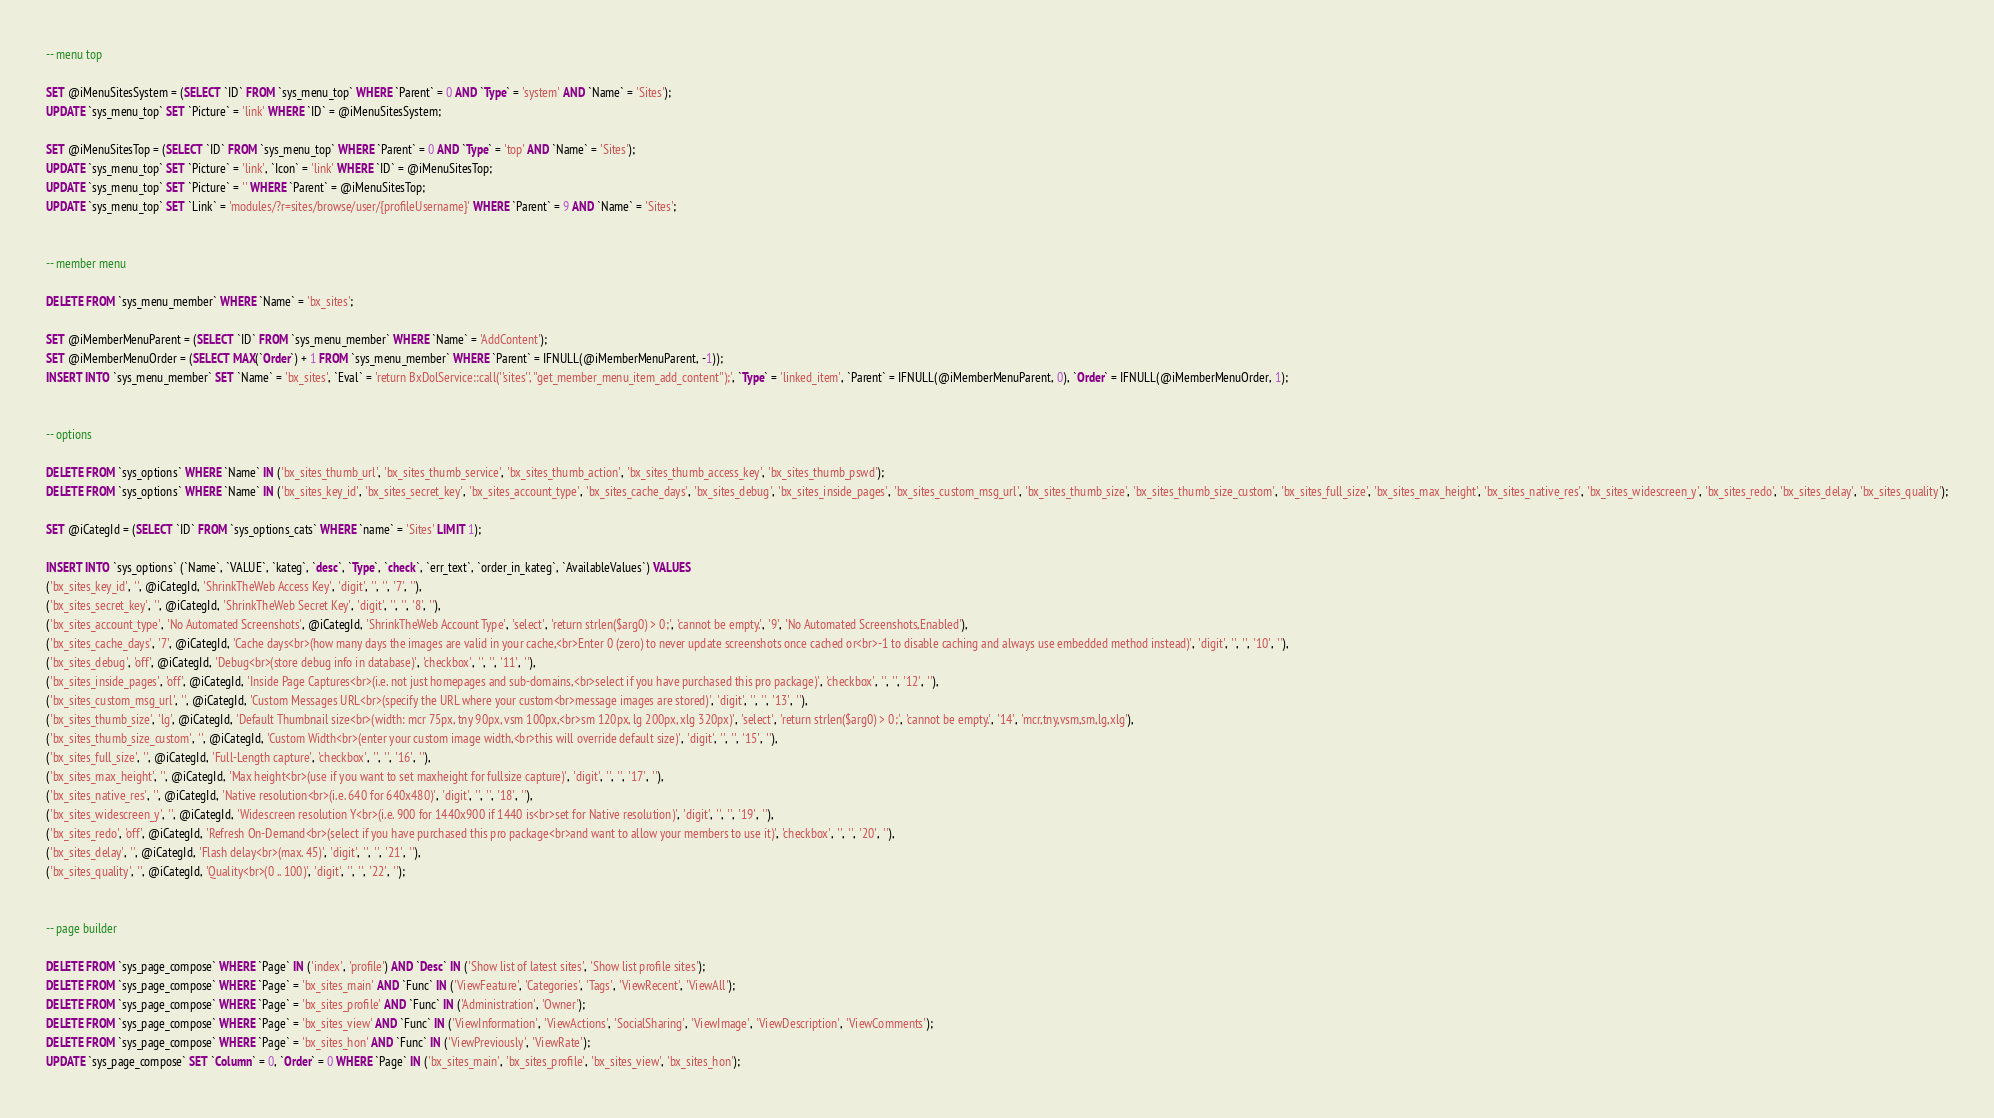<code> <loc_0><loc_0><loc_500><loc_500><_SQL_>
-- menu top

SET @iMenuSitesSystem = (SELECT `ID` FROM `sys_menu_top` WHERE `Parent` = 0 AND `Type` = 'system' AND `Name` = 'Sites');
UPDATE `sys_menu_top` SET `Picture` = 'link' WHERE `ID` = @iMenuSitesSystem;

SET @iMenuSitesTop = (SELECT `ID` FROM `sys_menu_top` WHERE `Parent` = 0 AND `Type` = 'top' AND `Name` = 'Sites');
UPDATE `sys_menu_top` SET `Picture` = 'link', `Icon` = 'link' WHERE `ID` = @iMenuSitesTop;
UPDATE `sys_menu_top` SET `Picture` = '' WHERE `Parent` = @iMenuSitesTop;
UPDATE `sys_menu_top` SET `Link` = 'modules/?r=sites/browse/user/{profileUsername}' WHERE `Parent` = 9 AND `Name` = 'Sites';


-- member menu

DELETE FROM `sys_menu_member` WHERE `Name` = 'bx_sites';

SET @iMemberMenuParent = (SELECT `ID` FROM `sys_menu_member` WHERE `Name` = 'AddContent');
SET @iMemberMenuOrder = (SELECT MAX(`Order`) + 1 FROM `sys_menu_member` WHERE `Parent` = IFNULL(@iMemberMenuParent, -1));
INSERT INTO `sys_menu_member` SET `Name` = 'bx_sites', `Eval` = 'return BxDolService::call(''sites'', ''get_member_menu_item_add_content'');', `Type` = 'linked_item', `Parent` = IFNULL(@iMemberMenuParent, 0), `Order` = IFNULL(@iMemberMenuOrder, 1);


-- options

DELETE FROM `sys_options` WHERE `Name` IN ('bx_sites_thumb_url', 'bx_sites_thumb_service', 'bx_sites_thumb_action', 'bx_sites_thumb_access_key', 'bx_sites_thumb_pswd');
DELETE FROM `sys_options` WHERE `Name` IN ('bx_sites_key_id', 'bx_sites_secret_key', 'bx_sites_account_type', 'bx_sites_cache_days', 'bx_sites_debug', 'bx_sites_inside_pages', 'bx_sites_custom_msg_url', 'bx_sites_thumb_size', 'bx_sites_thumb_size_custom', 'bx_sites_full_size', 'bx_sites_max_height', 'bx_sites_native_res', 'bx_sites_widescreen_y', 'bx_sites_redo', 'bx_sites_delay', 'bx_sites_quality');

SET @iCategId = (SELECT `ID` FROM `sys_options_cats` WHERE `name` = 'Sites' LIMIT 1);

INSERT INTO `sys_options` (`Name`, `VALUE`, `kateg`, `desc`, `Type`, `check`, `err_text`, `order_in_kateg`, `AvailableValues`) VALUES
('bx_sites_key_id', '', @iCategId, 'ShrinkTheWeb Access Key', 'digit', '', '', '7', ''),
('bx_sites_secret_key', '', @iCategId, 'ShrinkTheWeb Secret Key', 'digit', '', '', '8', ''),
('bx_sites_account_type', 'No Automated Screenshots', @iCategId, 'ShrinkTheWeb Account Type', 'select', 'return strlen($arg0) > 0;', 'cannot be empty.', '9', 'No Automated Screenshots,Enabled'),
('bx_sites_cache_days', '7', @iCategId, 'Cache days<br>(how many days the images are valid in your cache,<br>Enter 0 (zero) to never update screenshots once cached or<br>-1 to disable caching and always use embedded method instead)', 'digit', '', '', '10', ''),
('bx_sites_debug', 'off', @iCategId, 'Debug<br>(store debug info in database)', 'checkbox', '', '', '11', ''),
('bx_sites_inside_pages', 'off', @iCategId, 'Inside Page Captures<br>(i.e. not just homepages and sub-domains,<br>select if you have purchased this pro package)', 'checkbox', '', '', '12', ''),
('bx_sites_custom_msg_url', '', @iCategId, 'Custom Messages URL<br>(specify the URL where your custom<br>message images are stored)', 'digit', '', '', '13', ''),
('bx_sites_thumb_size', 'lg', @iCategId, 'Default Thumbnail size<br>(width: mcr 75px, tny 90px, vsm 100px,<br>sm 120px, lg 200px, xlg 320px)', 'select', 'return strlen($arg0) > 0;', 'cannot be empty.', '14', 'mcr,tny,vsm,sm,lg,xlg'),
('bx_sites_thumb_size_custom', '', @iCategId, 'Custom Width<br>(enter your custom image width,<br>this will override default size)', 'digit', '', '', '15', ''),
('bx_sites_full_size', '', @iCategId, 'Full-Length capture', 'checkbox', '', '', '16', ''),
('bx_sites_max_height', '', @iCategId, 'Max height<br>(use if you want to set maxheight for fullsize capture)', 'digit', '', '', '17', ''),
('bx_sites_native_res', '', @iCategId, 'Native resolution<br>(i.e. 640 for 640x480)', 'digit', '', '', '18', ''),
('bx_sites_widescreen_y', '', @iCategId, 'Widescreen resolution Y<br>(i.e. 900 for 1440x900 if 1440 is<br>set for Native resolution)', 'digit', '', '', '19', ''),
('bx_sites_redo', 'off', @iCategId, 'Refresh On-Demand<br>(select if you have purchased this pro package<br>and want to allow your members to use it)', 'checkbox', '', '', '20', ''),
('bx_sites_delay', '', @iCategId, 'Flash delay<br>(max. 45)', 'digit', '', '', '21', ''),
('bx_sites_quality', '', @iCategId, 'Quality<br>(0 .. 100)', 'digit', '', '', '22', '');


-- page builder 

DELETE FROM `sys_page_compose` WHERE `Page` IN ('index', 'profile') AND `Desc` IN ('Show list of latest sites', 'Show list profile sites');
DELETE FROM `sys_page_compose` WHERE `Page` = 'bx_sites_main' AND `Func` IN ('ViewFeature', 'Categories', 'Tags', 'ViewRecent', 'ViewAll');
DELETE FROM `sys_page_compose` WHERE `Page` = 'bx_sites_profile' AND `Func` IN ('Administration', 'Owner');
DELETE FROM `sys_page_compose` WHERE `Page` = 'bx_sites_view' AND `Func` IN ('ViewInformation', 'ViewActions', 'SocialSharing', 'ViewImage', 'ViewDescription', 'ViewComments');
DELETE FROM `sys_page_compose` WHERE `Page` = 'bx_sites_hon' AND `Func` IN ('ViewPreviously', 'ViewRate');
UPDATE `sys_page_compose` SET `Column` = 0, `Order` = 0 WHERE `Page` IN ('bx_sites_main', 'bx_sites_profile', 'bx_sites_view', 'bx_sites_hon');
</code> 